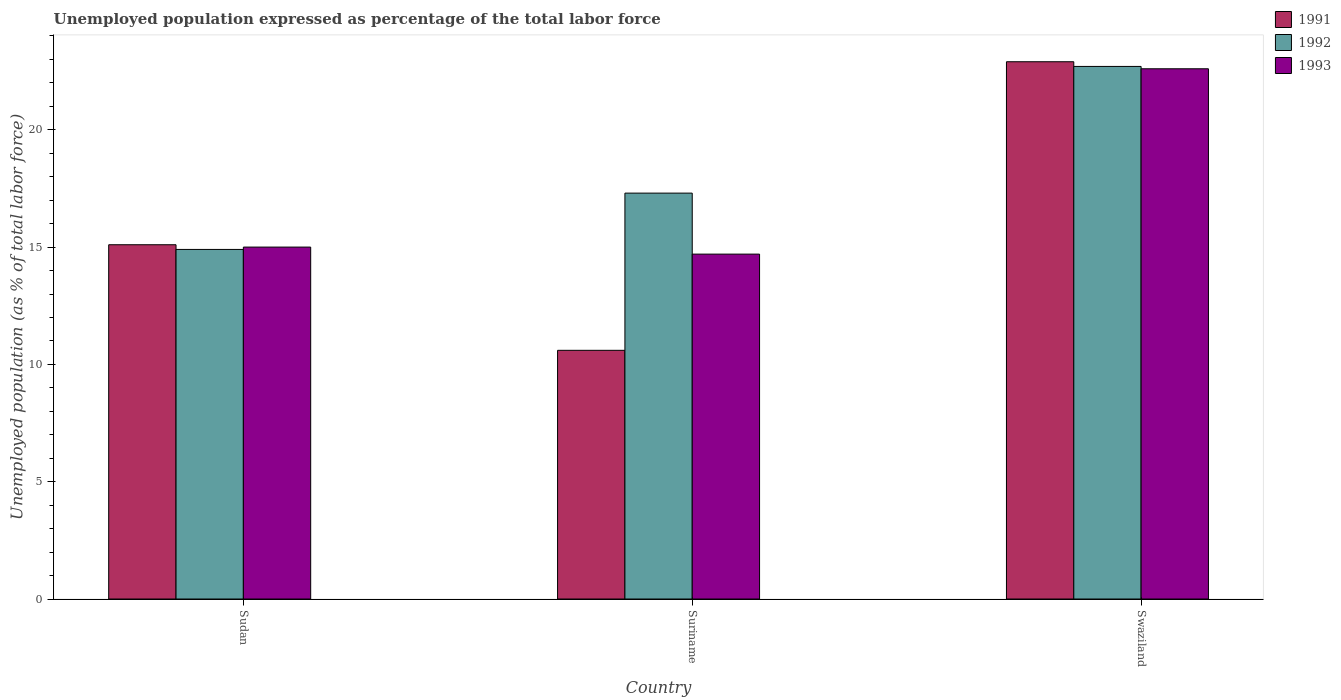How many groups of bars are there?
Offer a very short reply. 3. Are the number of bars on each tick of the X-axis equal?
Your response must be concise. Yes. How many bars are there on the 2nd tick from the left?
Provide a short and direct response. 3. How many bars are there on the 1st tick from the right?
Provide a short and direct response. 3. What is the label of the 2nd group of bars from the left?
Your response must be concise. Suriname. What is the unemployment in in 1992 in Sudan?
Provide a succinct answer. 14.9. Across all countries, what is the maximum unemployment in in 1993?
Provide a succinct answer. 22.6. Across all countries, what is the minimum unemployment in in 1992?
Your response must be concise. 14.9. In which country was the unemployment in in 1991 maximum?
Offer a terse response. Swaziland. In which country was the unemployment in in 1992 minimum?
Your answer should be very brief. Sudan. What is the total unemployment in in 1991 in the graph?
Your answer should be compact. 48.6. What is the difference between the unemployment in in 1993 in Sudan and that in Swaziland?
Provide a short and direct response. -7.6. What is the difference between the unemployment in in 1991 in Suriname and the unemployment in in 1992 in Swaziland?
Give a very brief answer. -12.1. What is the average unemployment in in 1991 per country?
Offer a terse response. 16.2. What is the difference between the unemployment in of/in 1992 and unemployment in of/in 1993 in Swaziland?
Offer a very short reply. 0.1. In how many countries, is the unemployment in in 1993 greater than 11 %?
Your answer should be compact. 3. What is the ratio of the unemployment in in 1993 in Sudan to that in Suriname?
Your answer should be very brief. 1.02. What is the difference between the highest and the second highest unemployment in in 1992?
Ensure brevity in your answer.  -5.4. What is the difference between the highest and the lowest unemployment in in 1992?
Offer a terse response. 7.8. In how many countries, is the unemployment in in 1993 greater than the average unemployment in in 1993 taken over all countries?
Provide a short and direct response. 1. Is the sum of the unemployment in in 1992 in Sudan and Suriname greater than the maximum unemployment in in 1991 across all countries?
Offer a very short reply. Yes. What does the 3rd bar from the left in Suriname represents?
Offer a terse response. 1993. Is it the case that in every country, the sum of the unemployment in in 1993 and unemployment in in 1991 is greater than the unemployment in in 1992?
Your response must be concise. Yes. How many countries are there in the graph?
Your response must be concise. 3. How many legend labels are there?
Offer a terse response. 3. What is the title of the graph?
Give a very brief answer. Unemployed population expressed as percentage of the total labor force. What is the label or title of the Y-axis?
Your answer should be compact. Unemployed population (as % of total labor force). What is the Unemployed population (as % of total labor force) in 1991 in Sudan?
Offer a very short reply. 15.1. What is the Unemployed population (as % of total labor force) of 1992 in Sudan?
Your answer should be very brief. 14.9. What is the Unemployed population (as % of total labor force) in 1991 in Suriname?
Provide a succinct answer. 10.6. What is the Unemployed population (as % of total labor force) in 1992 in Suriname?
Your answer should be compact. 17.3. What is the Unemployed population (as % of total labor force) in 1993 in Suriname?
Offer a very short reply. 14.7. What is the Unemployed population (as % of total labor force) in 1991 in Swaziland?
Ensure brevity in your answer.  22.9. What is the Unemployed population (as % of total labor force) in 1992 in Swaziland?
Keep it short and to the point. 22.7. What is the Unemployed population (as % of total labor force) in 1993 in Swaziland?
Make the answer very short. 22.6. Across all countries, what is the maximum Unemployed population (as % of total labor force) in 1991?
Give a very brief answer. 22.9. Across all countries, what is the maximum Unemployed population (as % of total labor force) of 1992?
Make the answer very short. 22.7. Across all countries, what is the maximum Unemployed population (as % of total labor force) of 1993?
Keep it short and to the point. 22.6. Across all countries, what is the minimum Unemployed population (as % of total labor force) in 1991?
Make the answer very short. 10.6. Across all countries, what is the minimum Unemployed population (as % of total labor force) in 1992?
Offer a terse response. 14.9. Across all countries, what is the minimum Unemployed population (as % of total labor force) of 1993?
Your answer should be very brief. 14.7. What is the total Unemployed population (as % of total labor force) of 1991 in the graph?
Give a very brief answer. 48.6. What is the total Unemployed population (as % of total labor force) in 1992 in the graph?
Ensure brevity in your answer.  54.9. What is the total Unemployed population (as % of total labor force) in 1993 in the graph?
Provide a succinct answer. 52.3. What is the difference between the Unemployed population (as % of total labor force) of 1991 in Sudan and that in Suriname?
Give a very brief answer. 4.5. What is the difference between the Unemployed population (as % of total labor force) of 1992 in Sudan and that in Suriname?
Your answer should be compact. -2.4. What is the difference between the Unemployed population (as % of total labor force) in 1991 in Sudan and that in Swaziland?
Offer a terse response. -7.8. What is the difference between the Unemployed population (as % of total labor force) in 1993 in Sudan and that in Swaziland?
Your answer should be compact. -7.6. What is the difference between the Unemployed population (as % of total labor force) of 1991 in Suriname and that in Swaziland?
Provide a short and direct response. -12.3. What is the difference between the Unemployed population (as % of total labor force) in 1992 in Suriname and that in Swaziland?
Keep it short and to the point. -5.4. What is the difference between the Unemployed population (as % of total labor force) in 1993 in Suriname and that in Swaziland?
Your answer should be compact. -7.9. What is the difference between the Unemployed population (as % of total labor force) of 1991 in Sudan and the Unemployed population (as % of total labor force) of 1992 in Suriname?
Your response must be concise. -2.2. What is the difference between the Unemployed population (as % of total labor force) in 1991 in Sudan and the Unemployed population (as % of total labor force) in 1993 in Suriname?
Offer a terse response. 0.4. What is the difference between the Unemployed population (as % of total labor force) of 1992 in Sudan and the Unemployed population (as % of total labor force) of 1993 in Suriname?
Offer a very short reply. 0.2. What is the difference between the Unemployed population (as % of total labor force) in 1991 in Sudan and the Unemployed population (as % of total labor force) in 1993 in Swaziland?
Offer a terse response. -7.5. What is the difference between the Unemployed population (as % of total labor force) in 1991 in Suriname and the Unemployed population (as % of total labor force) in 1992 in Swaziland?
Offer a terse response. -12.1. What is the difference between the Unemployed population (as % of total labor force) of 1991 in Suriname and the Unemployed population (as % of total labor force) of 1993 in Swaziland?
Provide a succinct answer. -12. What is the difference between the Unemployed population (as % of total labor force) of 1992 in Suriname and the Unemployed population (as % of total labor force) of 1993 in Swaziland?
Offer a very short reply. -5.3. What is the average Unemployed population (as % of total labor force) of 1992 per country?
Give a very brief answer. 18.3. What is the average Unemployed population (as % of total labor force) in 1993 per country?
Your answer should be very brief. 17.43. What is the difference between the Unemployed population (as % of total labor force) of 1991 and Unemployed population (as % of total labor force) of 1992 in Sudan?
Make the answer very short. 0.2. What is the difference between the Unemployed population (as % of total labor force) of 1991 and Unemployed population (as % of total labor force) of 1993 in Sudan?
Ensure brevity in your answer.  0.1. What is the difference between the Unemployed population (as % of total labor force) of 1992 and Unemployed population (as % of total labor force) of 1993 in Sudan?
Your answer should be very brief. -0.1. What is the difference between the Unemployed population (as % of total labor force) in 1991 and Unemployed population (as % of total labor force) in 1992 in Suriname?
Your answer should be very brief. -6.7. What is the difference between the Unemployed population (as % of total labor force) in 1992 and Unemployed population (as % of total labor force) in 1993 in Suriname?
Offer a very short reply. 2.6. What is the difference between the Unemployed population (as % of total labor force) in 1991 and Unemployed population (as % of total labor force) in 1992 in Swaziland?
Your answer should be very brief. 0.2. What is the difference between the Unemployed population (as % of total labor force) of 1992 and Unemployed population (as % of total labor force) of 1993 in Swaziland?
Keep it short and to the point. 0.1. What is the ratio of the Unemployed population (as % of total labor force) in 1991 in Sudan to that in Suriname?
Your answer should be compact. 1.42. What is the ratio of the Unemployed population (as % of total labor force) in 1992 in Sudan to that in Suriname?
Keep it short and to the point. 0.86. What is the ratio of the Unemployed population (as % of total labor force) in 1993 in Sudan to that in Suriname?
Provide a short and direct response. 1.02. What is the ratio of the Unemployed population (as % of total labor force) in 1991 in Sudan to that in Swaziland?
Ensure brevity in your answer.  0.66. What is the ratio of the Unemployed population (as % of total labor force) in 1992 in Sudan to that in Swaziland?
Your answer should be compact. 0.66. What is the ratio of the Unemployed population (as % of total labor force) in 1993 in Sudan to that in Swaziland?
Your answer should be very brief. 0.66. What is the ratio of the Unemployed population (as % of total labor force) in 1991 in Suriname to that in Swaziland?
Your answer should be compact. 0.46. What is the ratio of the Unemployed population (as % of total labor force) in 1992 in Suriname to that in Swaziland?
Your response must be concise. 0.76. What is the ratio of the Unemployed population (as % of total labor force) in 1993 in Suriname to that in Swaziland?
Your answer should be compact. 0.65. What is the difference between the highest and the second highest Unemployed population (as % of total labor force) of 1991?
Offer a very short reply. 7.8. What is the difference between the highest and the second highest Unemployed population (as % of total labor force) in 1992?
Make the answer very short. 5.4. What is the difference between the highest and the second highest Unemployed population (as % of total labor force) in 1993?
Your answer should be very brief. 7.6. What is the difference between the highest and the lowest Unemployed population (as % of total labor force) in 1992?
Your answer should be very brief. 7.8. 